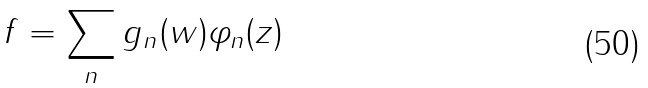<formula> <loc_0><loc_0><loc_500><loc_500>f = \sum _ { n } g _ { n } ( w ) \varphi _ { n } ( z )</formula> 